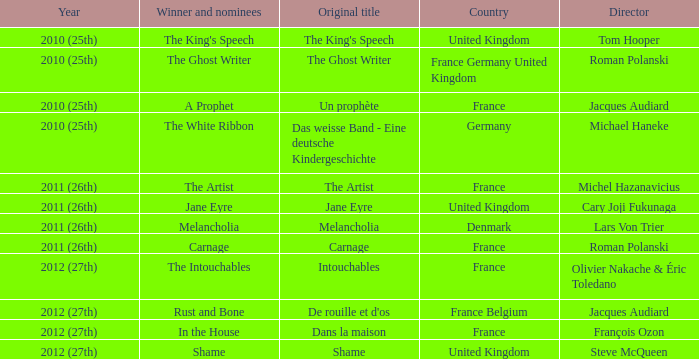Who was the person behind directing the king's speech? Tom Hooper. 